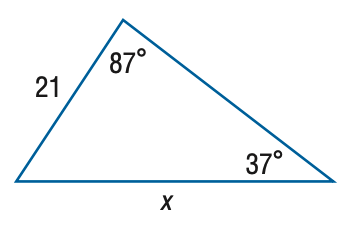Question: Find x. Round the side measure to the nearest tenth.
Choices:
A. 12.7
B. 15.2
C. 28.9
D. 34.8
Answer with the letter. Answer: D 